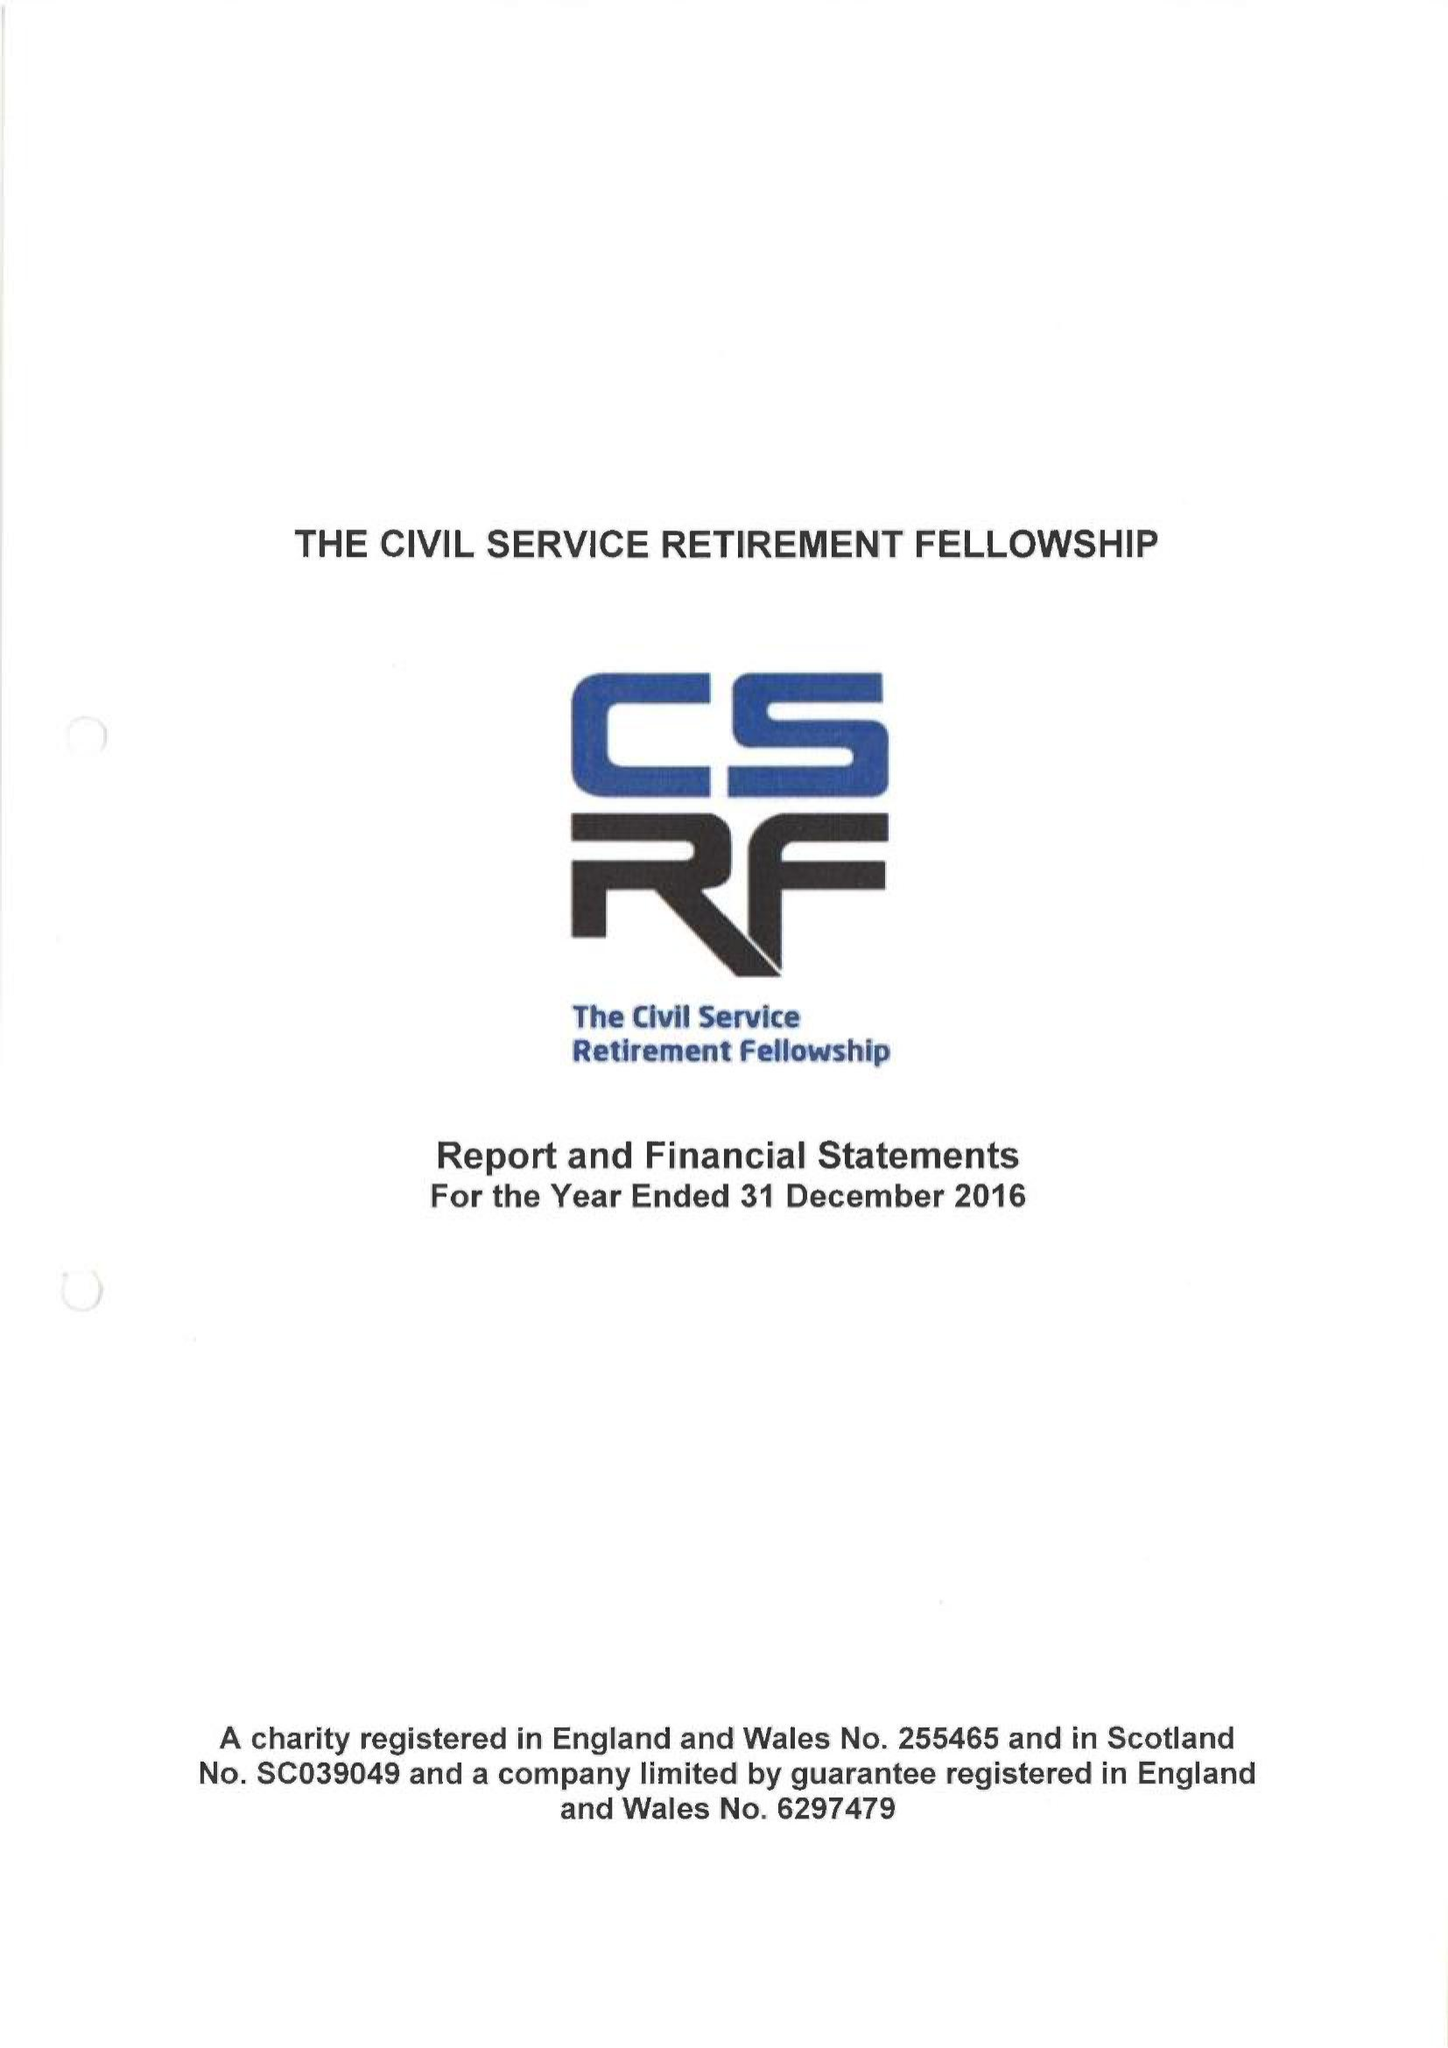What is the value for the charity_name?
Answer the question using a single word or phrase. The Civil Service Retirement Fellowship 